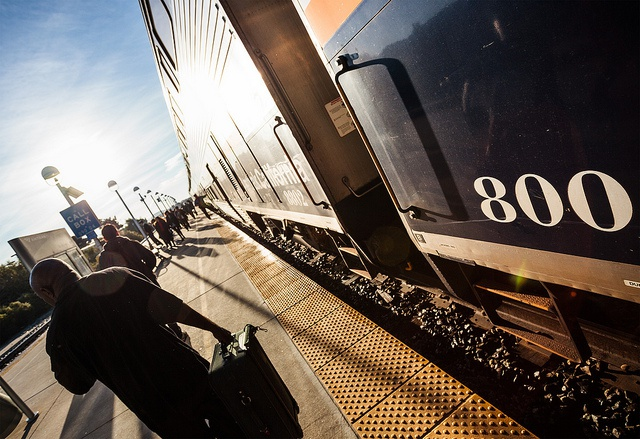Describe the objects in this image and their specific colors. I can see train in gray, black, white, and maroon tones, people in gray, black, tan, and maroon tones, suitcase in gray, black, and tan tones, people in gray and black tones, and backpack in gray and black tones in this image. 